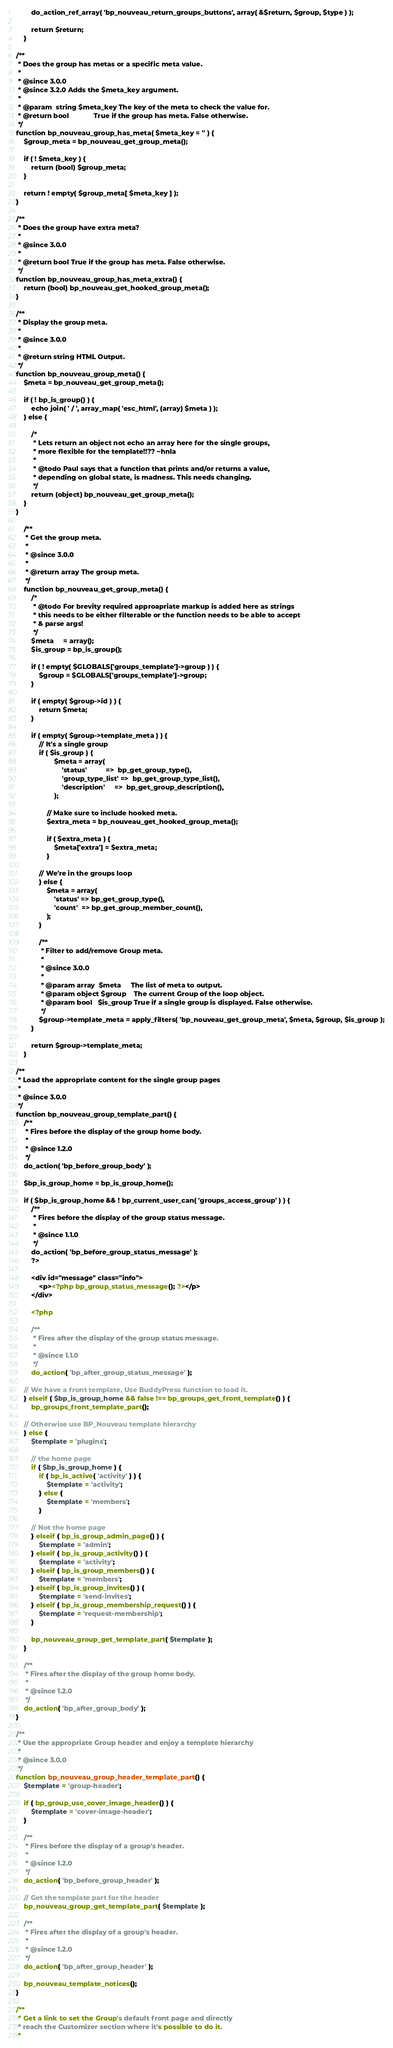<code> <loc_0><loc_0><loc_500><loc_500><_PHP_>		do_action_ref_array( 'bp_nouveau_return_groups_buttons', array( &$return, $group, $type ) );

		return $return;
	}

/**
 * Does the group has metas or a specific meta value.
 *
 * @since 3.0.0
 * @since 3.2.0 Adds the $meta_key argument.
 *
 * @param  string $meta_key The key of the meta to check the value for.
 * @return bool             True if the group has meta. False otherwise.
 */
function bp_nouveau_group_has_meta( $meta_key = '' ) {
	$group_meta = bp_nouveau_get_group_meta();

	if ( ! $meta_key ) {
		return (bool) $group_meta;
	}

	return ! empty( $group_meta[ $meta_key ] );
}

/**
 * Does the group have extra meta?
 *
 * @since 3.0.0
 *
 * @return bool True if the group has meta. False otherwise.
 */
function bp_nouveau_group_has_meta_extra() {
	return (bool) bp_nouveau_get_hooked_group_meta();
}

/**
 * Display the group meta.
 *
 * @since 3.0.0
 *
 * @return string HTML Output.
 */
function bp_nouveau_group_meta() {
	$meta = bp_nouveau_get_group_meta();

	if ( ! bp_is_group() ) {
		echo join( ' / ', array_map( 'esc_html', (array) $meta ) );
	} else {

		/*
		 * Lets return an object not echo an array here for the single groups,
		 * more flexible for the template!!?? ~hnla
		 *
		 * @todo Paul says that a function that prints and/or returns a value,
		 * depending on global state, is madness. This needs changing.
		 */
		return (object) bp_nouveau_get_group_meta();
	}
}

	/**
	 * Get the group meta.
	 *
	 * @since 3.0.0
	 *
	 * @return array The group meta.
	 */
	function bp_nouveau_get_group_meta() {
		/*
		 * @todo For brevity required approapriate markup is added here as strings
		 * this needs to be either filterable or the function needs to be able to accept
		 * & parse args!
		 */
		$meta     = array();
		$is_group = bp_is_group();

		if ( ! empty( $GLOBALS['groups_template']->group ) ) {
			$group = $GLOBALS['groups_template']->group;
		}

		if ( empty( $group->id ) ) {
			return $meta;
		}

		if ( empty( $group->template_meta ) ) {
			// It's a single group
			if ( $is_group ) {
					$meta = array(
						'status'          =>  bp_get_group_type(),
						'group_type_list' =>  bp_get_group_type_list(),
						'description'     =>  bp_get_group_description(),
					);

				// Make sure to include hooked meta.
				$extra_meta = bp_nouveau_get_hooked_group_meta();

				if ( $extra_meta ) {
					$meta['extra'] = $extra_meta;
				}

			// We're in the groups loop
			} else {
				$meta = array(
					'status' => bp_get_group_type(),
					'count'  => bp_get_group_member_count(),
				);
			}

			/**
			 * Filter to add/remove Group meta.
			 *
			 * @since 3.0.0
			 *
			 * @param array  $meta     The list of meta to output.
			 * @param object $group    The current Group of the loop object.
			 * @param bool   $is_group True if a single group is displayed. False otherwise.
			 */
			$group->template_meta = apply_filters( 'bp_nouveau_get_group_meta', $meta, $group, $is_group );
		}

		return $group->template_meta;
	}

/**
 * Load the appropriate content for the single group pages
 *
 * @since 3.0.0
 */
function bp_nouveau_group_template_part() {
	/**
	 * Fires before the display of the group home body.
	 *
	 * @since 1.2.0
	 */
	do_action( 'bp_before_group_body' );

	$bp_is_group_home = bp_is_group_home();

	if ( $bp_is_group_home && ! bp_current_user_can( 'groups_access_group' ) ) {
		/**
		 * Fires before the display of the group status message.
		 *
		 * @since 1.1.0
		 */
		do_action( 'bp_before_group_status_message' );
		?>

		<div id="message" class="info">
			<p><?php bp_group_status_message(); ?></p>
		</div>

		<?php

		/**
		 * Fires after the display of the group status message.
		 *
		 * @since 1.1.0
		 */
		do_action( 'bp_after_group_status_message' );

	// We have a front template, Use BuddyPress function to load it.
	} elseif ( $bp_is_group_home && false !== bp_groups_get_front_template() ) {
		bp_groups_front_template_part();

	// Otherwise use BP_Nouveau template hierarchy
	} else {
		$template = 'plugins';

		// the home page
		if ( $bp_is_group_home ) {
			if ( bp_is_active( 'activity' ) ) {
				$template = 'activity';
			} else {
				$template = 'members';
			}

		// Not the home page
		} elseif ( bp_is_group_admin_page() ) {
			$template = 'admin';
		} elseif ( bp_is_group_activity() ) {
			$template = 'activity';
		} elseif ( bp_is_group_members() ) {
			$template = 'members';
		} elseif ( bp_is_group_invites() ) {
			$template = 'send-invites';
		} elseif ( bp_is_group_membership_request() ) {
			$template = 'request-membership';
		}

		bp_nouveau_group_get_template_part( $template );
	}

	/**
	 * Fires after the display of the group home body.
	 *
	 * @since 1.2.0
	 */
	do_action( 'bp_after_group_body' );
}

/**
 * Use the appropriate Group header and enjoy a template hierarchy
 *
 * @since 3.0.0
 */
function bp_nouveau_group_header_template_part() {
	$template = 'group-header';

	if ( bp_group_use_cover_image_header() ) {
		$template = 'cover-image-header';
	}

	/**
	 * Fires before the display of a group's header.
	 *
	 * @since 1.2.0
	 */
	do_action( 'bp_before_group_header' );

	// Get the template part for the header
	bp_nouveau_group_get_template_part( $template );

	/**
	 * Fires after the display of a group's header.
	 *
	 * @since 1.2.0
	 */
	do_action( 'bp_after_group_header' );

	bp_nouveau_template_notices();
}

/**
 * Get a link to set the Group's default front page and directly
 * reach the Customizer section where it's possible to do it.
 *</code> 